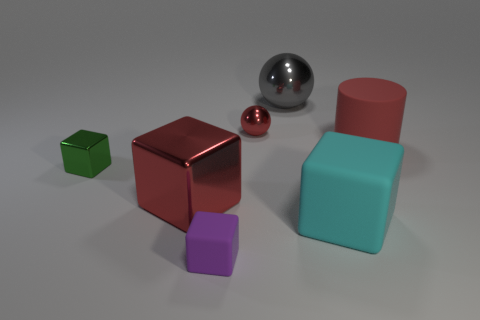What number of large red rubber objects are the same shape as the gray shiny object?
Your response must be concise. 0. There is a big gray metal thing to the right of the red metal thing that is in front of the small metallic thing that is on the right side of the tiny rubber block; what shape is it?
Make the answer very short. Sphere. There is a big thing that is behind the large matte cube and in front of the big red rubber cylinder; what material is it made of?
Your answer should be very brief. Metal. Do the red metallic object behind the rubber cylinder and the large red cube have the same size?
Your answer should be very brief. No. Is there any other thing that has the same size as the cyan matte thing?
Give a very brief answer. Yes. Are there more small purple things to the right of the red cylinder than spheres in front of the small green metal cube?
Ensure brevity in your answer.  No. The tiny cube that is on the left side of the large shiny object that is in front of the rubber object that is right of the big cyan matte cube is what color?
Offer a very short reply. Green. There is a small matte thing that is in front of the big cyan thing; is it the same color as the big metal ball?
Ensure brevity in your answer.  No. How many other things are the same color as the tiny metallic block?
Ensure brevity in your answer.  0. How many things are either small blue rubber spheres or large cyan things?
Make the answer very short. 1. 